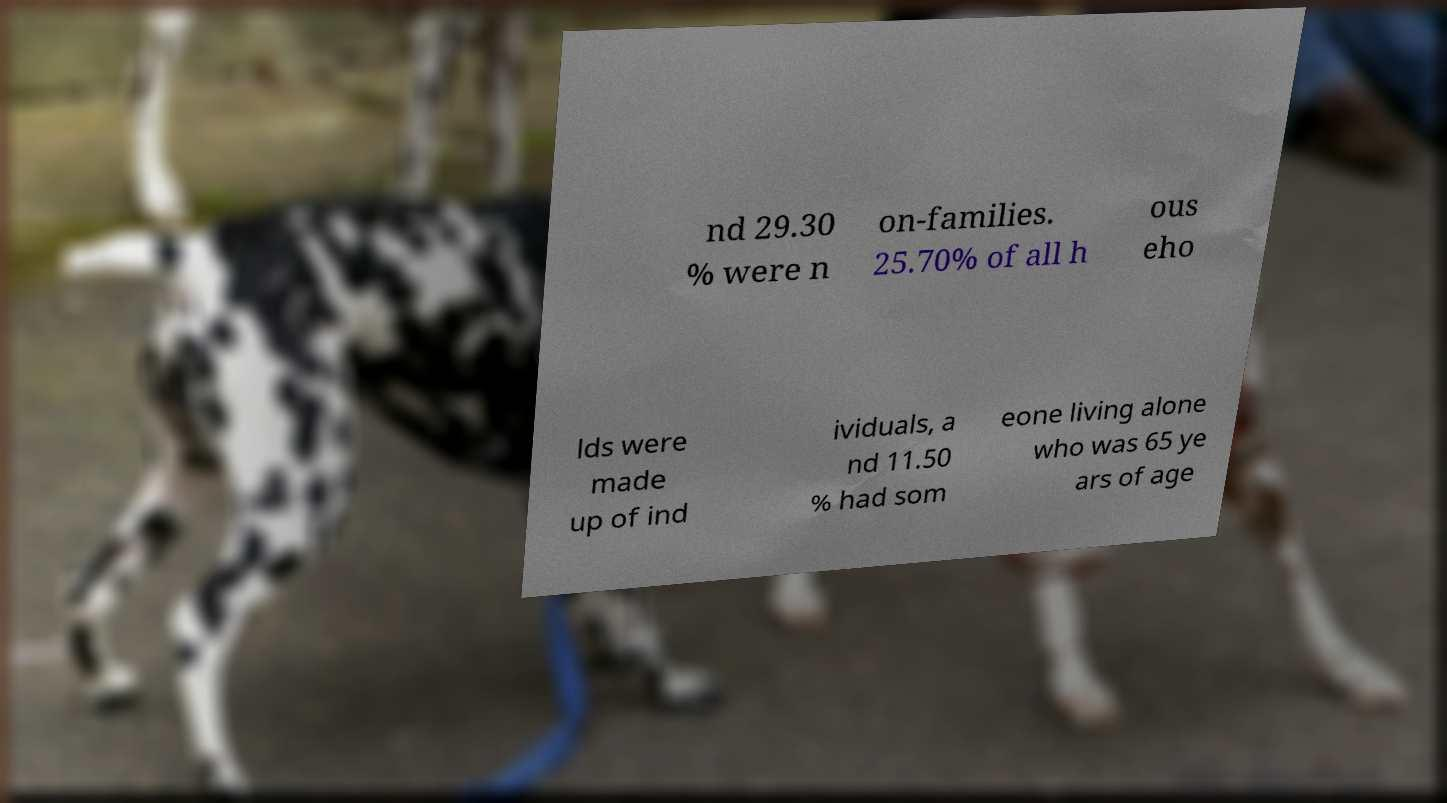For documentation purposes, I need the text within this image transcribed. Could you provide that? nd 29.30 % were n on-families. 25.70% of all h ous eho lds were made up of ind ividuals, a nd 11.50 % had som eone living alone who was 65 ye ars of age 